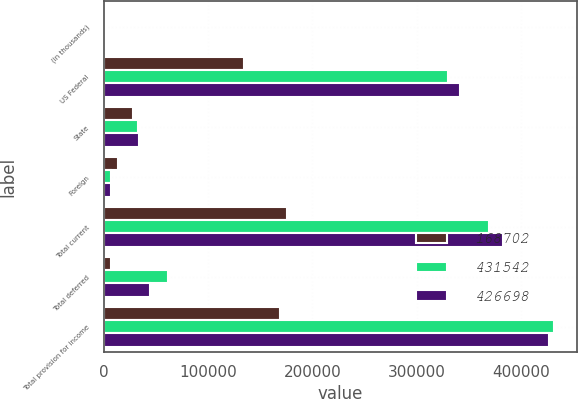Convert chart. <chart><loc_0><loc_0><loc_500><loc_500><stacked_bar_chart><ecel><fcel>(in thousands)<fcel>US Federal<fcel>State<fcel>Foreign<fcel>Total current<fcel>Total deferred<fcel>Total provision for income<nl><fcel>168702<fcel>2018<fcel>134869<fcel>27782<fcel>13492<fcel>176143<fcel>7441<fcel>168702<nl><fcel>431542<fcel>2017<fcel>329707<fcel>32719<fcel>6950<fcel>369376<fcel>62166<fcel>431542<nl><fcel>426698<fcel>2016<fcel>341799<fcel>33753<fcel>6819<fcel>382371<fcel>44327<fcel>426698<nl></chart> 